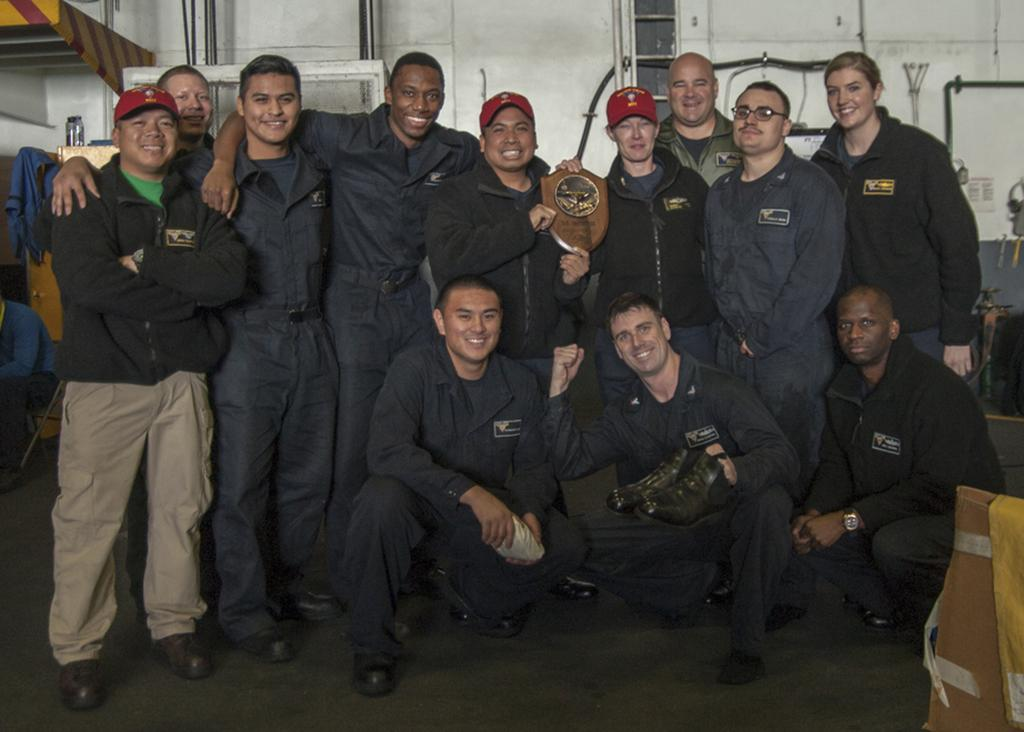What are the people in the image doing? The persons in the image are smiling and standing, while some are squatting on the floor. What can be seen in the background of the image? There is a white wall in the background of the image, along with a person sitting and other objects. What type of creature is sitting next to the person in the background? There is no creature present in the image; only people and objects are visible. What are the hobbies of the woman in the image? There is no woman specifically mentioned in the image, and therefore no hobbies can be attributed to her. 